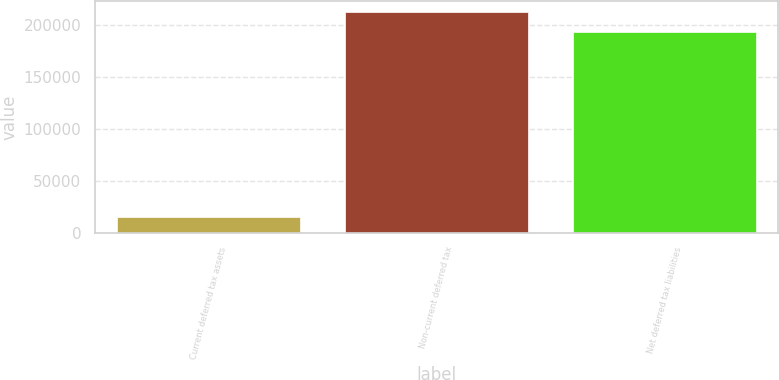Convert chart to OTSL. <chart><loc_0><loc_0><loc_500><loc_500><bar_chart><fcel>Current deferred tax assets<fcel>Non-current deferred tax<fcel>Net deferred tax liabilities<nl><fcel>15240<fcel>213003<fcel>193639<nl></chart> 